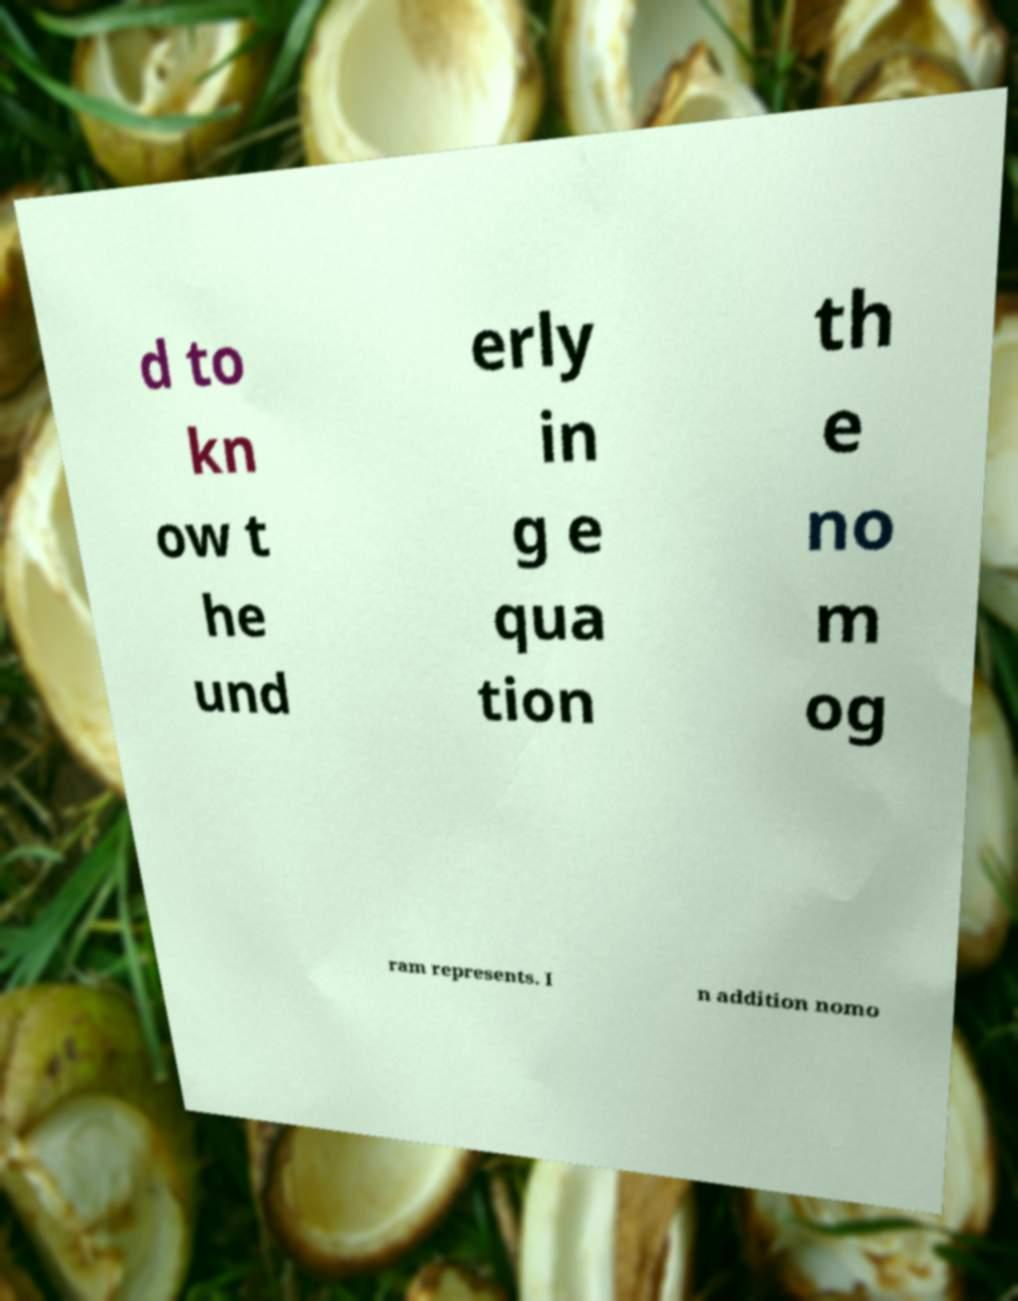There's text embedded in this image that I need extracted. Can you transcribe it verbatim? d to kn ow t he und erly in g e qua tion th e no m og ram represents. I n addition nomo 